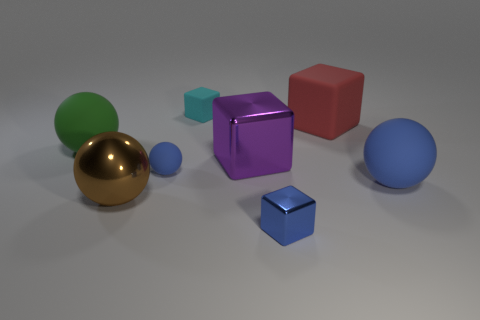What color is the large sphere that is behind the large rubber ball that is on the right side of the tiny matte thing in front of the small cyan rubber block?
Keep it short and to the point. Green. Do the small cube that is behind the brown metal object and the matte thing in front of the small blue matte thing have the same color?
Give a very brief answer. No. What number of red matte cubes are behind the matte ball to the right of the big red rubber thing?
Give a very brief answer. 1. Is there a small yellow matte thing?
Make the answer very short. No. How many other objects are there of the same color as the metal ball?
Your answer should be very brief. 0. Is the number of large brown metal balls less than the number of blue objects?
Offer a very short reply. Yes. There is a blue rubber thing that is left of the object that is on the right side of the large red thing; what shape is it?
Give a very brief answer. Sphere. Are there any large green things on the left side of the tiny ball?
Your answer should be compact. Yes. What color is the shiny block that is the same size as the metallic ball?
Ensure brevity in your answer.  Purple. What number of cyan cubes are the same material as the green object?
Provide a short and direct response. 1. 